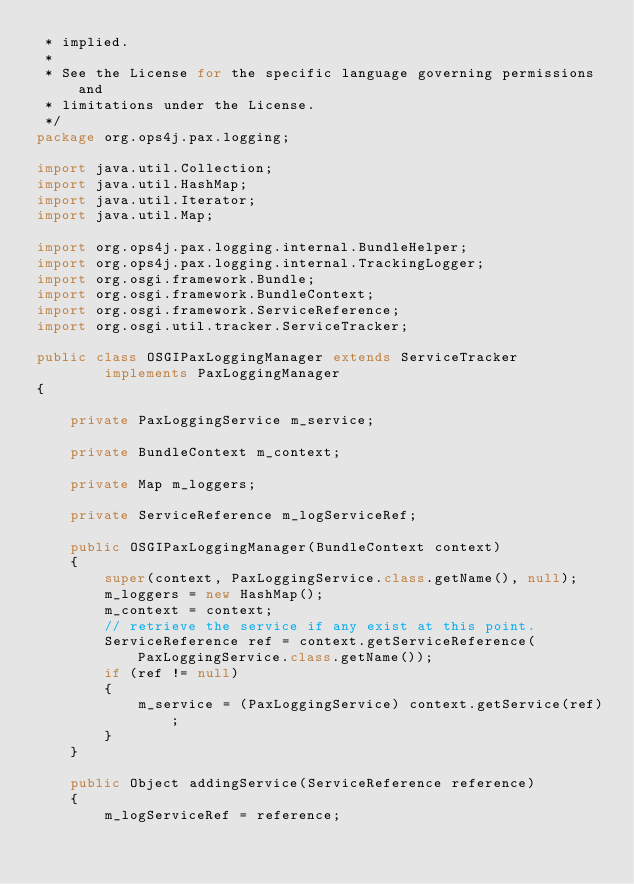Convert code to text. <code><loc_0><loc_0><loc_500><loc_500><_Java_> * implied.
 *
 * See the License for the specific language governing permissions and
 * limitations under the License. 
 */
package org.ops4j.pax.logging;

import java.util.Collection;
import java.util.HashMap;
import java.util.Iterator;
import java.util.Map;

import org.ops4j.pax.logging.internal.BundleHelper;
import org.ops4j.pax.logging.internal.TrackingLogger;
import org.osgi.framework.Bundle;
import org.osgi.framework.BundleContext;
import org.osgi.framework.ServiceReference;
import org.osgi.util.tracker.ServiceTracker;

public class OSGIPaxLoggingManager extends ServiceTracker
        implements PaxLoggingManager
{

    private PaxLoggingService m_service;

    private BundleContext m_context;

    private Map m_loggers;

    private ServiceReference m_logServiceRef;

    public OSGIPaxLoggingManager(BundleContext context)
    {
        super(context, PaxLoggingService.class.getName(), null);
        m_loggers = new HashMap();
        m_context = context;
        // retrieve the service if any exist at this point.
        ServiceReference ref = context.getServiceReference(PaxLoggingService.class.getName());
        if (ref != null)
        {
            m_service = (PaxLoggingService) context.getService(ref);
        }
    }

    public Object addingService(ServiceReference reference)
    {
        m_logServiceRef = reference;</code> 